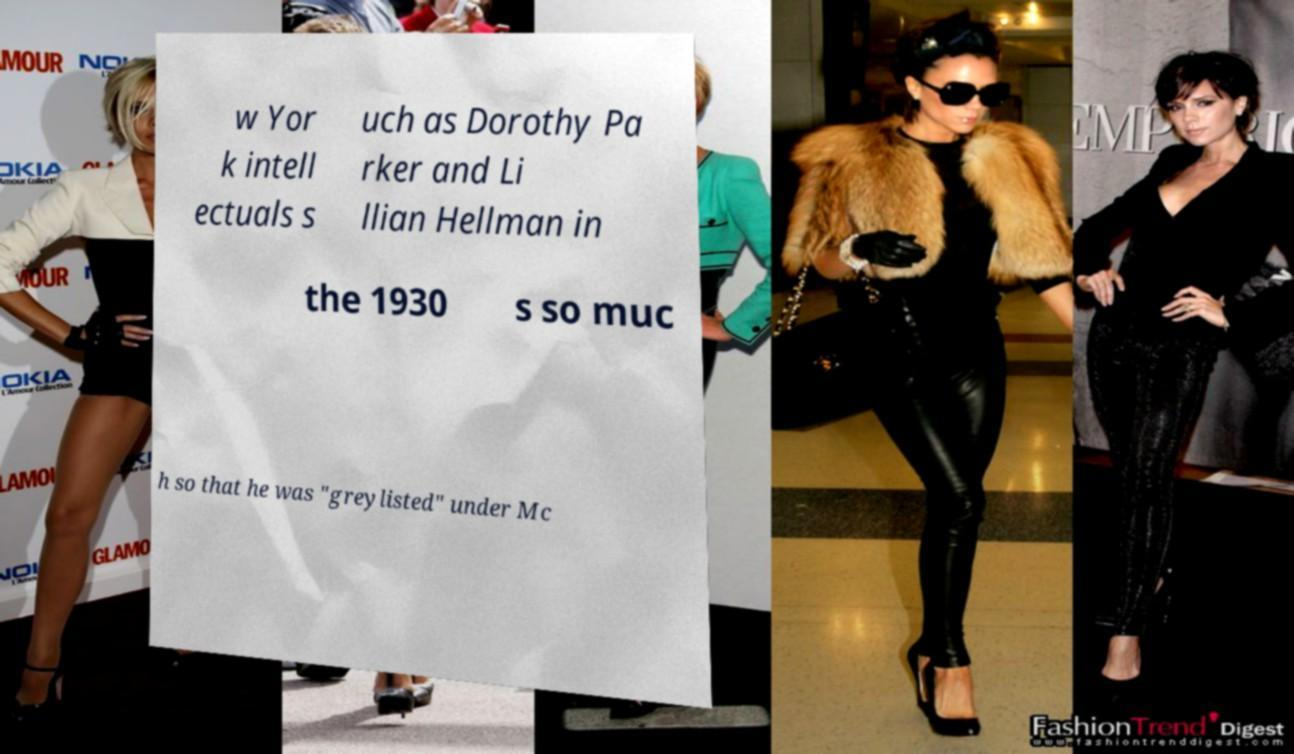Can you read and provide the text displayed in the image?This photo seems to have some interesting text. Can you extract and type it out for me? w Yor k intell ectuals s uch as Dorothy Pa rker and Li llian Hellman in the 1930 s so muc h so that he was "greylisted" under Mc 